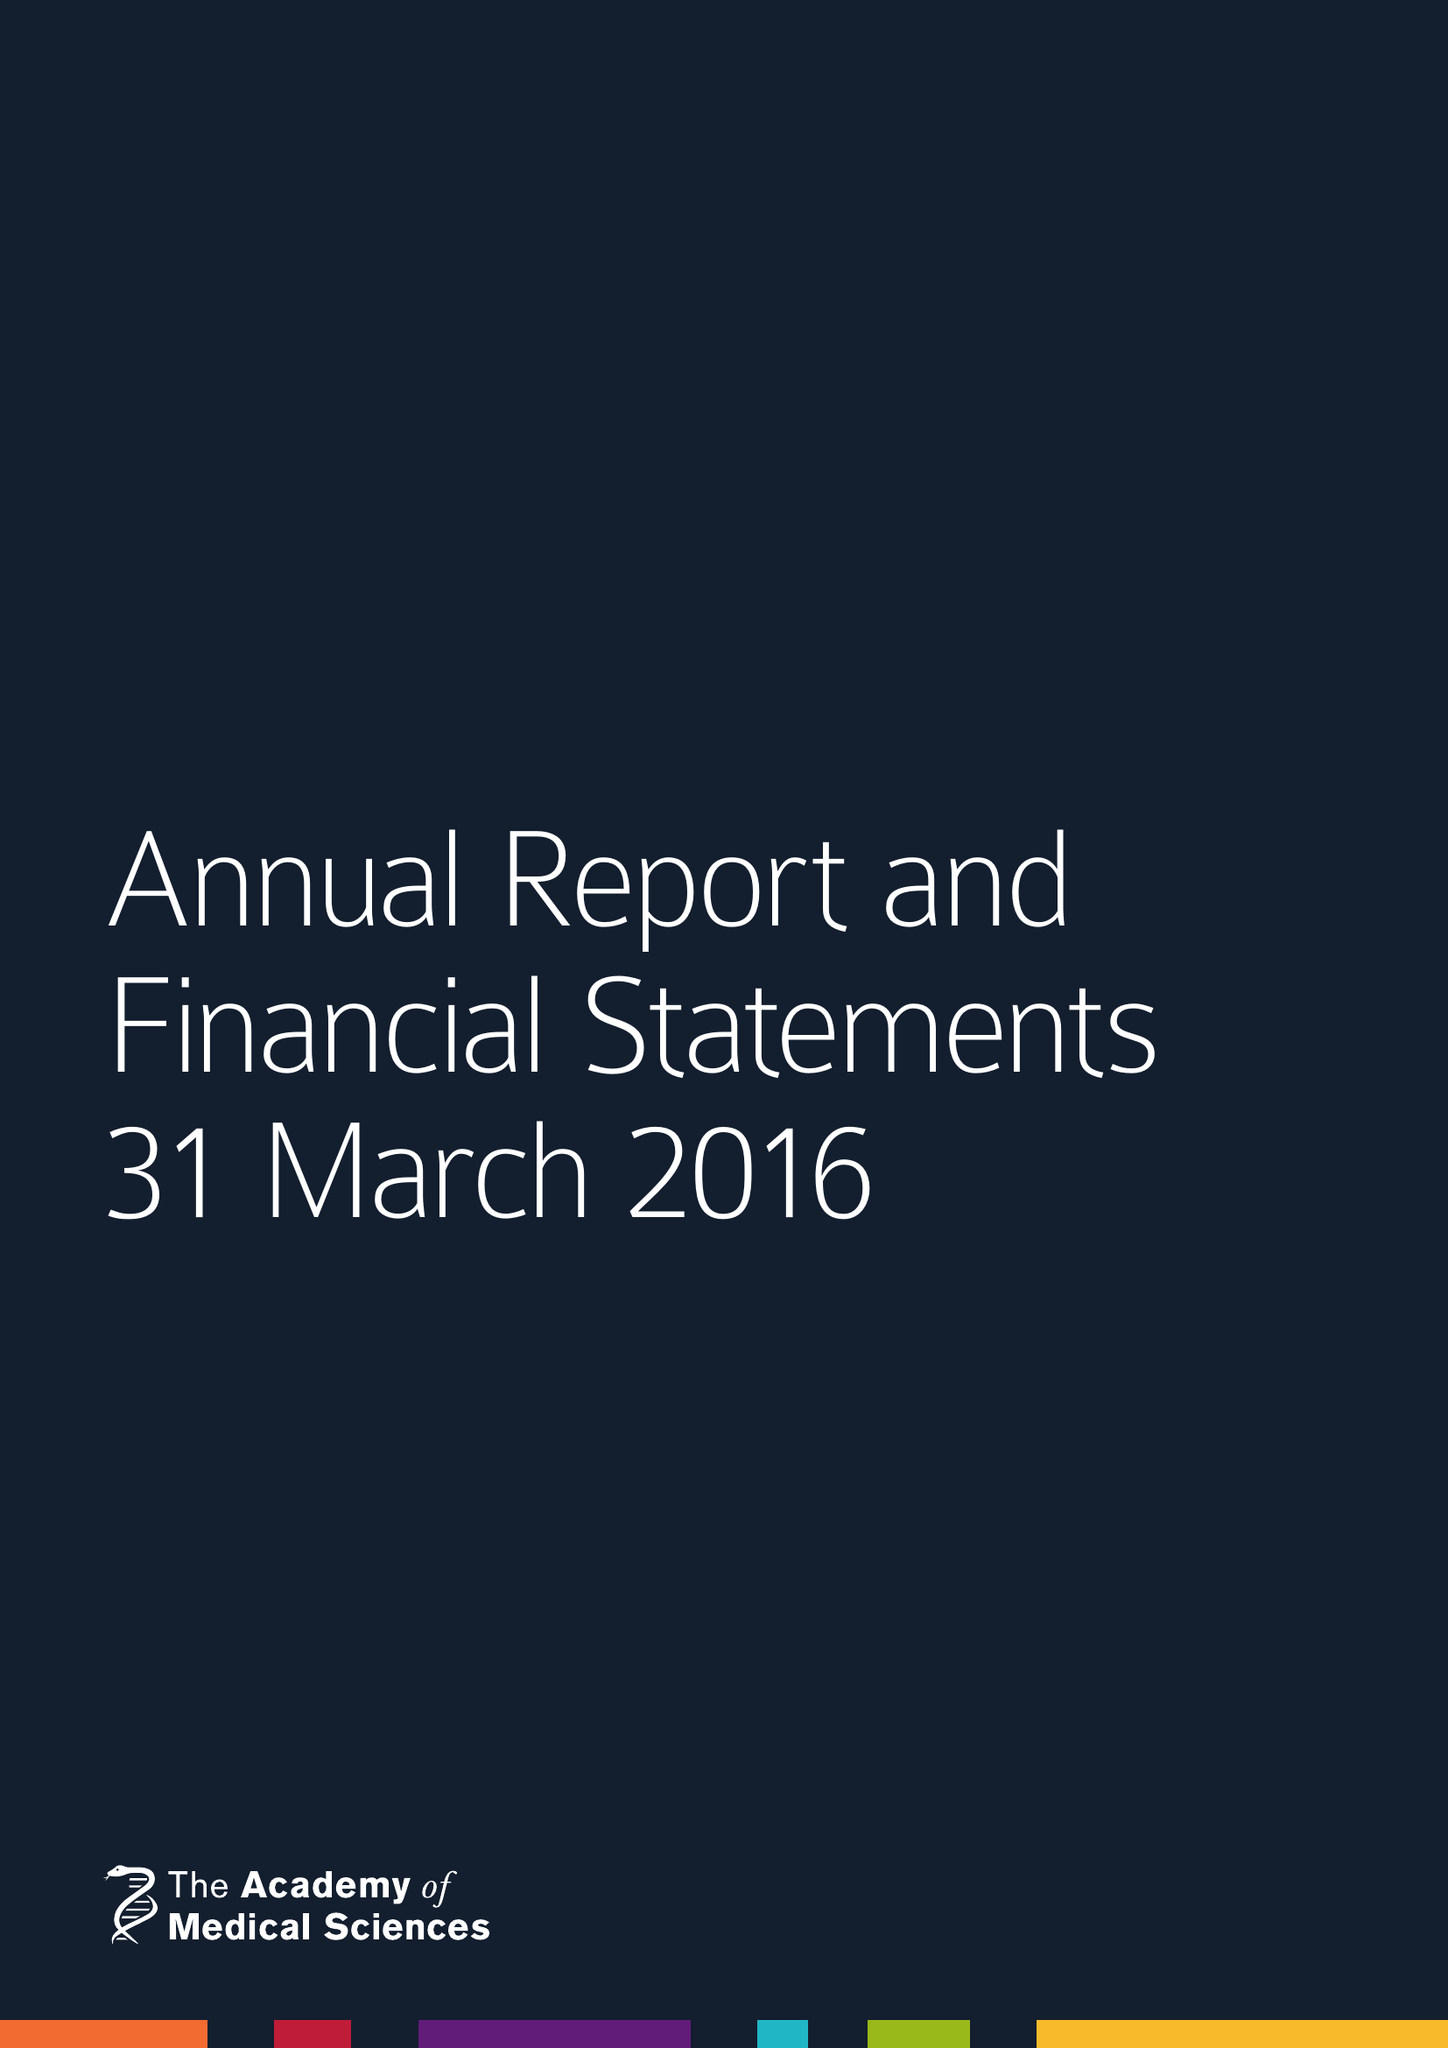What is the value for the spending_annually_in_british_pounds?
Answer the question using a single word or phrase. 7906307.00 